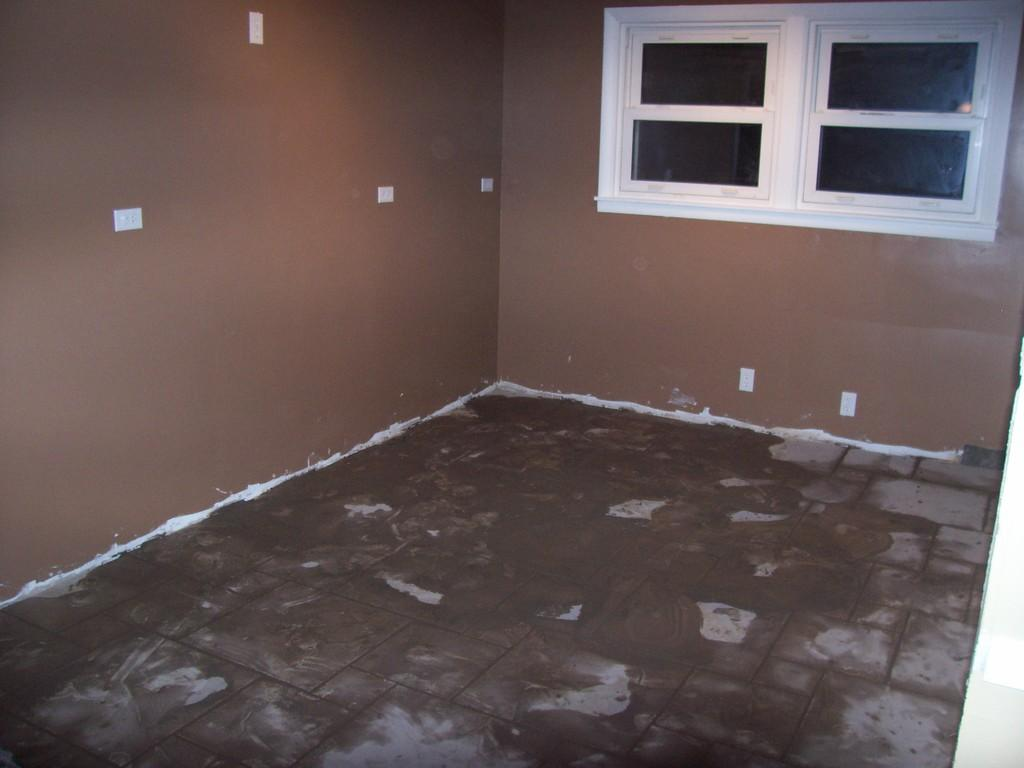What type of space is depicted in the image? The image is of a room. What is the surface that people walk on in the room? There is a floor in the room. What surrounds the room to separate it from other spaces? There are walls in the room. What allows natural light to enter the room? There are windows in the room. What type of mint plant can be seen growing on the floor in the image? There is no mint plant present in the image; the floor is a flat surface without any vegetation. 